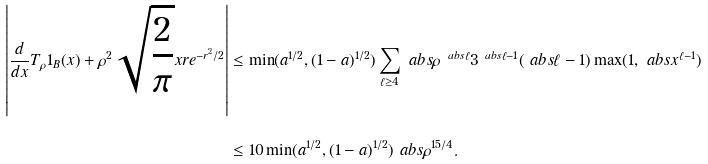Convert formula to latex. <formula><loc_0><loc_0><loc_500><loc_500>\left | \frac { d } { d x } T _ { \rho } 1 _ { B } ( x ) + \rho ^ { 2 } \sqrt { \frac { 2 } { \pi } } x r e ^ { - r ^ { 2 } / 2 } \right | & \leq \min ( a ^ { 1 / 2 } , ( 1 - a ) ^ { 1 / 2 } ) \sum _ { \ell \geq 4 } \ a b s { \rho } ^ { \ a b s { \ell } } 3 ^ { \ a b s { \ell } - 1 } ( \ a b s { \ell } - 1 ) \max ( 1 , \ a b s { x } ^ { \ell - 1 } ) \\ & \leq 1 0 \min ( a ^ { 1 / 2 } , ( 1 - a ) ^ { 1 / 2 } ) \ a b s { \rho } ^ { 1 5 / 4 } .</formula> 